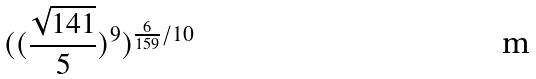<formula> <loc_0><loc_0><loc_500><loc_500>( ( \frac { \sqrt { 1 4 1 } } { 5 } ) ^ { 9 } ) ^ { \frac { 6 } { 1 5 9 } / 1 0 }</formula> 